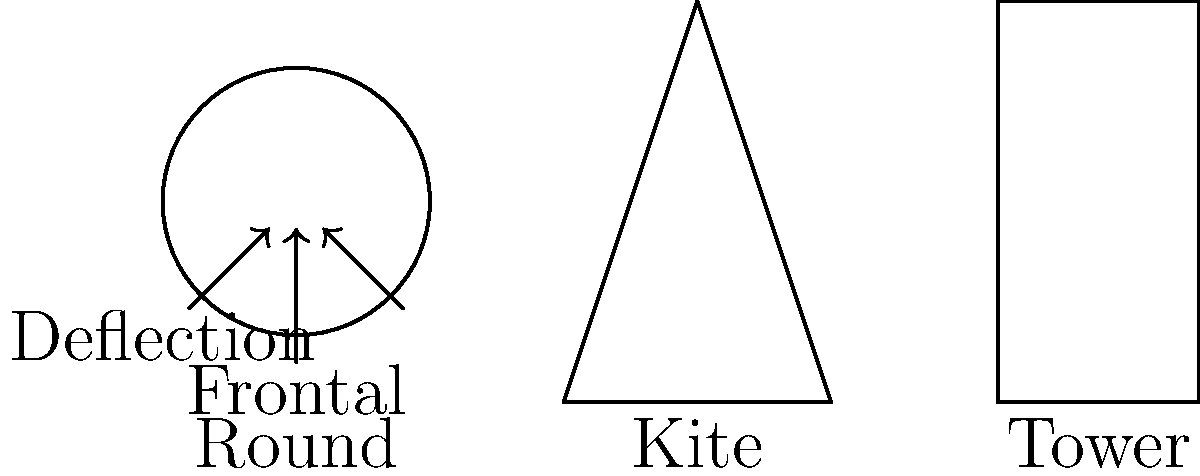Based on the biomechanical principles illustrated in the diagram, which shield design would be most effective against a variety of attack angles and why? To answer this question, we need to analyze the biomechanical advantages of each shield design:

1. Round Shield:
   - Provides equal protection from all angles
   - Curved surface helps deflect blows
   - Smaller surface area may leave parts of the body exposed

2. Kite Shield:
   - Tapered design allows for better maneuverability
   - Pointed bottom can be used for ground stability
   - Angled sides help deflect blows, but less effective than round shield

3. Tower Shield:
   - Largest surface area for maximum coverage
   - Flat surface doesn't deflect blows as effectively
   - Heavy and less maneuverable

Considering the variety of attack angles:
- Frontal attacks: All shields provide protection, but the tower shield offers the most coverage.
- Angled attacks: The round and kite shields are more effective at deflecting blows due to their shapes.
- Multiple angles: The round shield provides the most consistent protection from various angles.

The round shield's circular design offers the best compromise between deflection capability, maneuverability, and protection from multiple angles. Its curved surface efficiently redirects force from any angle of impact, reducing the strain on the user's arm and body. This biomechanical advantage makes it the most versatile and effective against a variety of attack angles.
Answer: Round shield, due to its versatile deflection capabilities and consistent protection from multiple angles. 